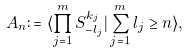Convert formula to latex. <formula><loc_0><loc_0><loc_500><loc_500>A _ { n } \colon = \langle \prod _ { j = 1 } ^ { m } S _ { - l _ { j } } ^ { k _ { j } } | \sum _ { j = 1 } ^ { m } l _ { j } \geq n \rangle ,</formula> 